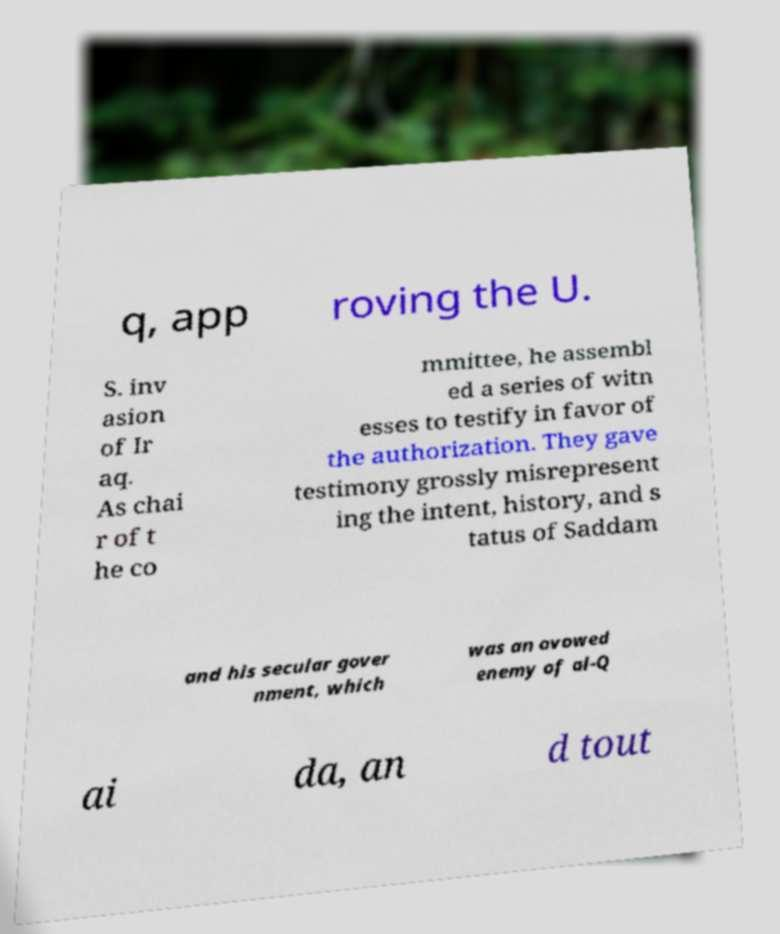There's text embedded in this image that I need extracted. Can you transcribe it verbatim? q, app roving the U. S. inv asion of Ir aq. As chai r of t he co mmittee, he assembl ed a series of witn esses to testify in favor of the authorization. They gave testimony grossly misrepresent ing the intent, history, and s tatus of Saddam and his secular gover nment, which was an avowed enemy of al-Q ai da, an d tout 